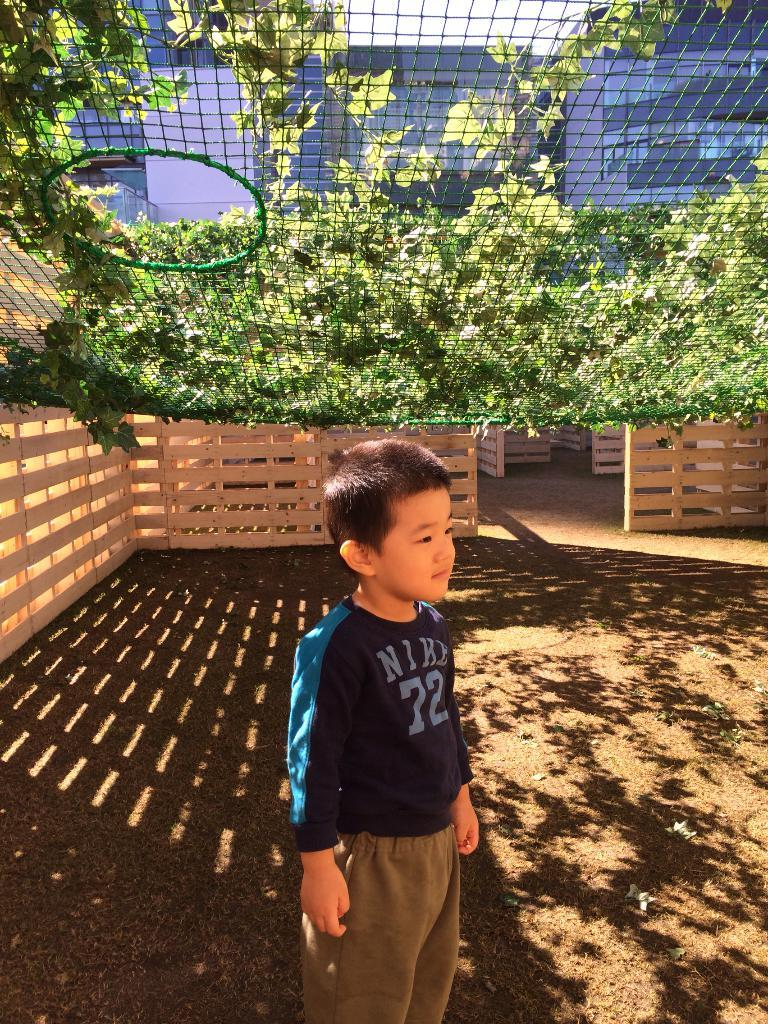What is the main subject of the image? The main subject of the image is a kid standing on the ground. What can be seen in the background of the image? There is a wooden fence, a mesh, creepers, buildings, and the sky visible in the image. How many eyes can be seen on the kid in the image? The image does not show the kid's eyes, so it is impossible to determine the number of eyes visible. What type of yam is being grown in the image? There is no yam present in the image; it features a kid standing on the ground and various elements in the background. 